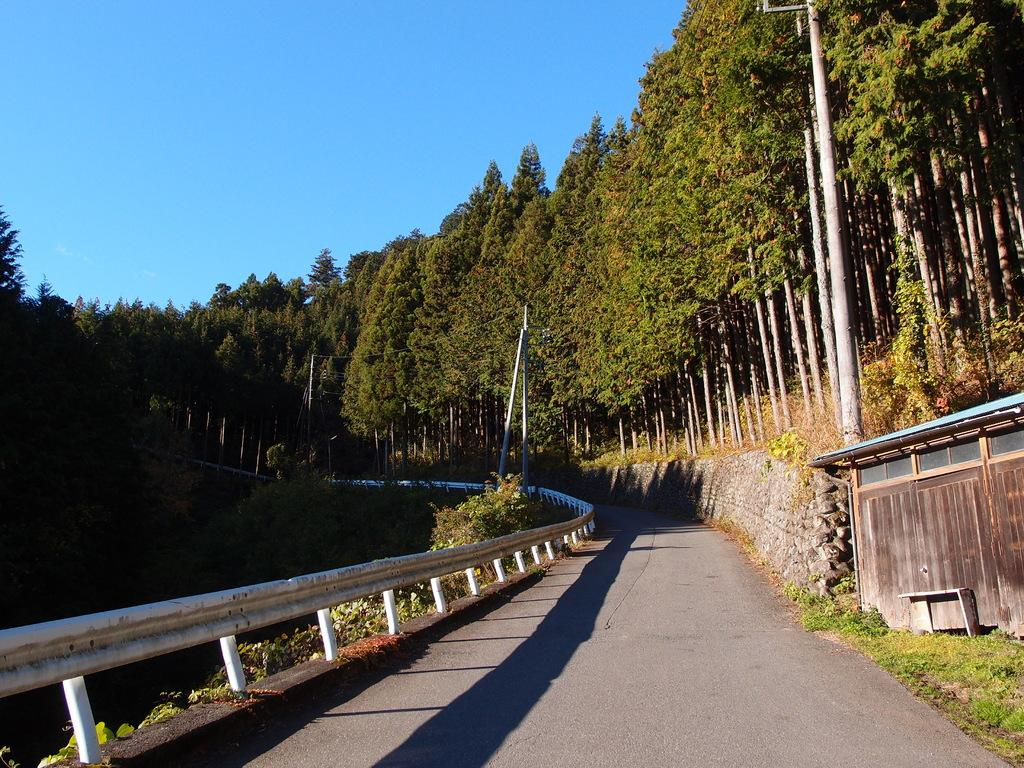What type of vegetation can be seen in the image? There are trees and plants in the image. What kind of pathway is present in the image? There is a road in the image. What type of barrier is visible in the image? There is fencing in the image. What type of structure can be seen in the image? There is a hut in the image. What part of the natural environment is visible in the image? The sky is visible in the image. How many boys are playing with the fan in the image? There are no boys or fans present in the image. What type of underwear is hanging on the hut in the image? There is no underwear present in the image; the hut is empty. 